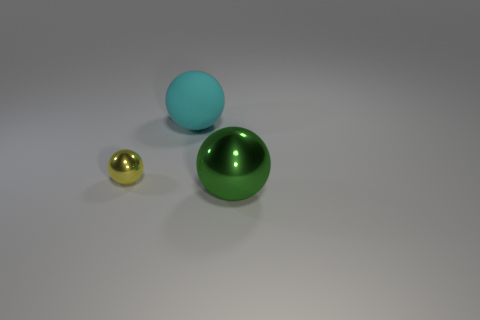Add 1 tiny green metal cubes. How many objects exist? 4 Add 3 yellow metal blocks. How many yellow metal blocks exist? 3 Subtract 0 brown balls. How many objects are left? 3 Subtract all big cyan matte things. Subtract all green spheres. How many objects are left? 1 Add 1 large balls. How many large balls are left? 3 